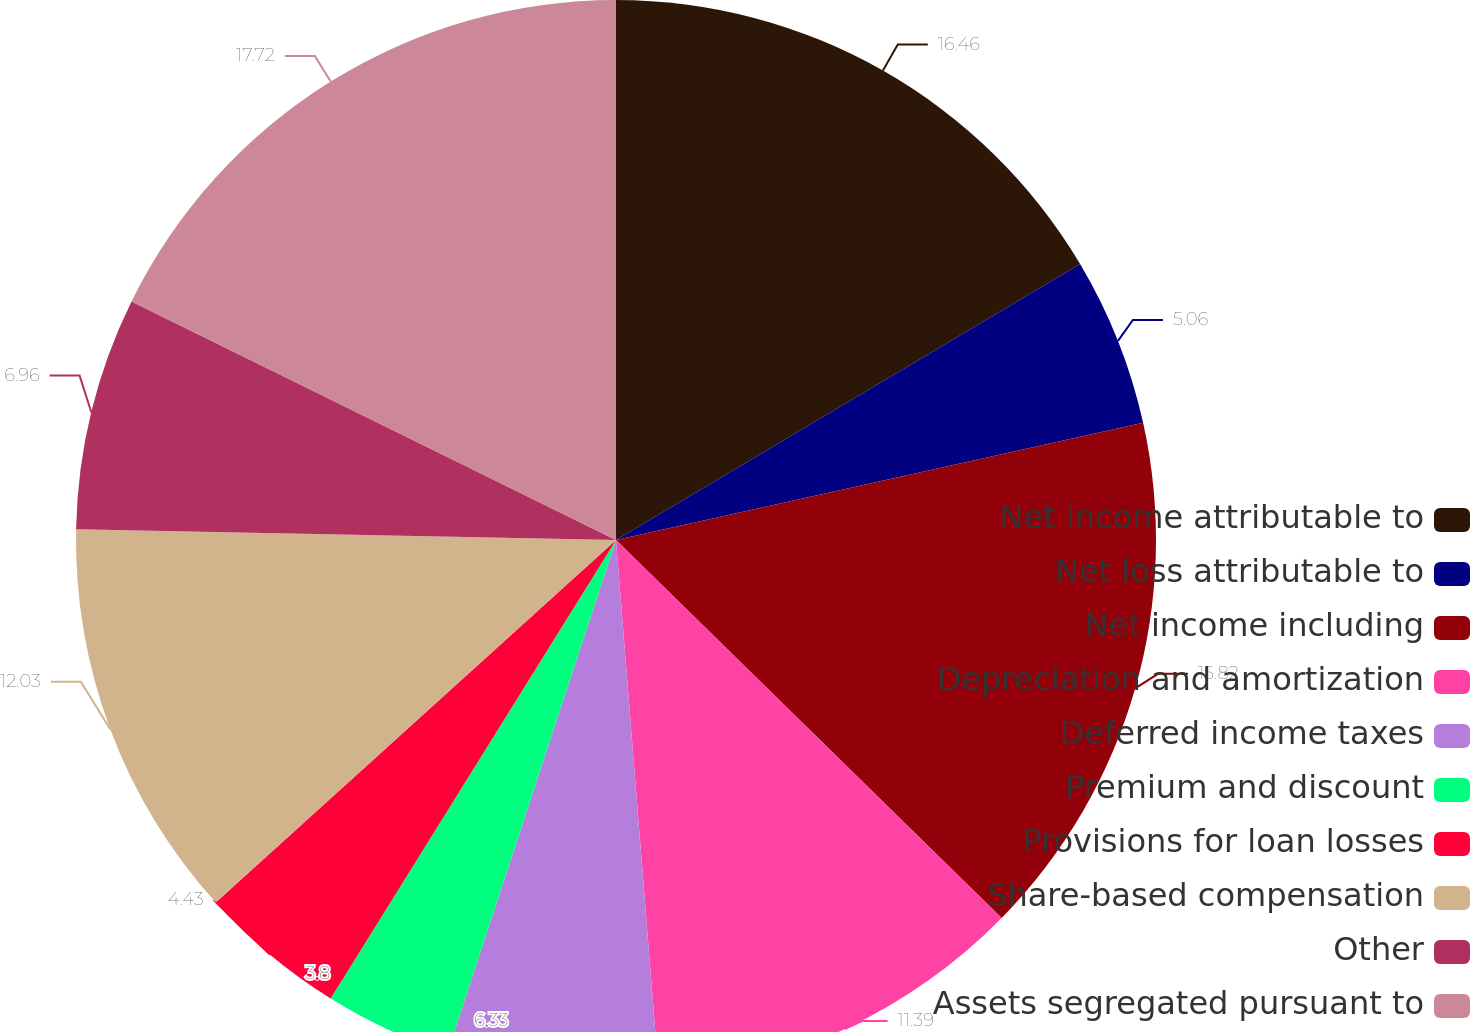Convert chart to OTSL. <chart><loc_0><loc_0><loc_500><loc_500><pie_chart><fcel>Net income attributable to<fcel>Net loss attributable to<fcel>Net income including<fcel>Depreciation and amortization<fcel>Deferred income taxes<fcel>Premium and discount<fcel>Provisions for loan losses<fcel>Share-based compensation<fcel>Other<fcel>Assets segregated pursuant to<nl><fcel>16.46%<fcel>5.06%<fcel>15.82%<fcel>11.39%<fcel>6.33%<fcel>3.8%<fcel>4.43%<fcel>12.03%<fcel>6.96%<fcel>17.72%<nl></chart> 